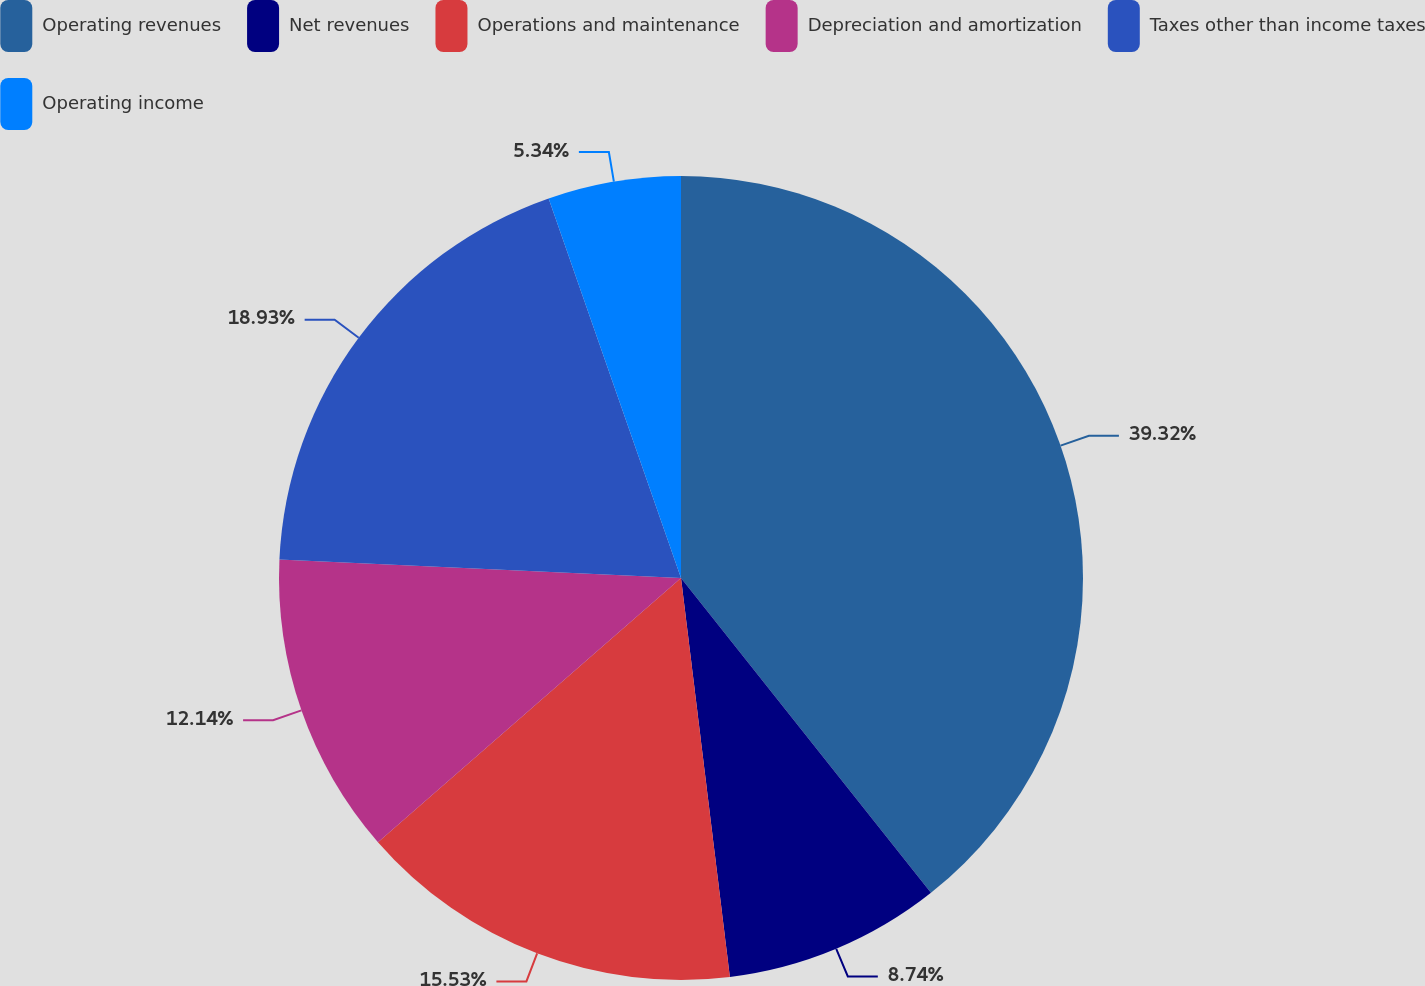Convert chart to OTSL. <chart><loc_0><loc_0><loc_500><loc_500><pie_chart><fcel>Operating revenues<fcel>Net revenues<fcel>Operations and maintenance<fcel>Depreciation and amortization<fcel>Taxes other than income taxes<fcel>Operating income<nl><fcel>39.32%<fcel>8.74%<fcel>15.53%<fcel>12.14%<fcel>18.93%<fcel>5.34%<nl></chart> 